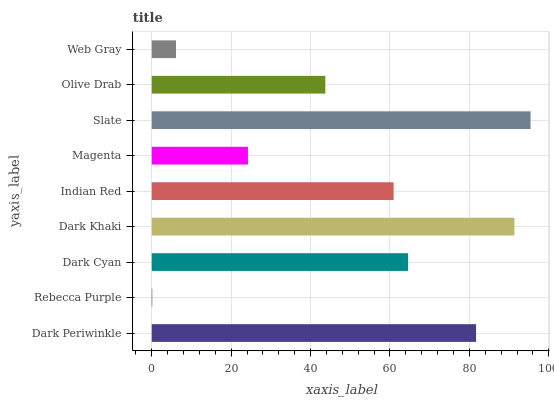Is Rebecca Purple the minimum?
Answer yes or no. Yes. Is Slate the maximum?
Answer yes or no. Yes. Is Dark Cyan the minimum?
Answer yes or no. No. Is Dark Cyan the maximum?
Answer yes or no. No. Is Dark Cyan greater than Rebecca Purple?
Answer yes or no. Yes. Is Rebecca Purple less than Dark Cyan?
Answer yes or no. Yes. Is Rebecca Purple greater than Dark Cyan?
Answer yes or no. No. Is Dark Cyan less than Rebecca Purple?
Answer yes or no. No. Is Indian Red the high median?
Answer yes or no. Yes. Is Indian Red the low median?
Answer yes or no. Yes. Is Olive Drab the high median?
Answer yes or no. No. Is Dark Cyan the low median?
Answer yes or no. No. 